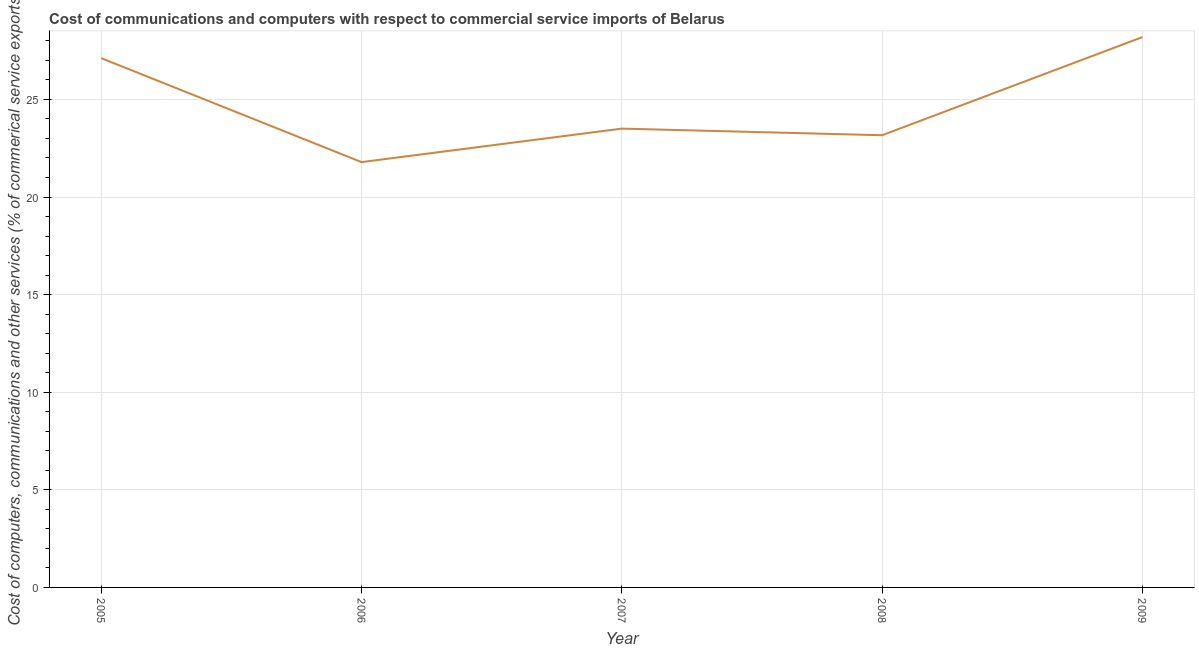What is the cost of communications in 2009?
Your answer should be very brief. 28.19. Across all years, what is the maximum  computer and other services?
Offer a very short reply. 28.19. Across all years, what is the minimum  computer and other services?
Keep it short and to the point. 21.79. In which year was the cost of communications maximum?
Ensure brevity in your answer.  2009. In which year was the cost of communications minimum?
Provide a short and direct response. 2006. What is the sum of the cost of communications?
Give a very brief answer. 123.77. What is the difference between the cost of communications in 2007 and 2008?
Your answer should be compact. 0.34. What is the average  computer and other services per year?
Offer a terse response. 24.75. What is the median cost of communications?
Keep it short and to the point. 23.5. Do a majority of the years between 2006 and 2007 (inclusive) have cost of communications greater than 15 %?
Give a very brief answer. Yes. What is the ratio of the cost of communications in 2007 to that in 2009?
Your answer should be very brief. 0.83. Is the  computer and other services in 2006 less than that in 2008?
Your answer should be compact. Yes. What is the difference between the highest and the second highest cost of communications?
Offer a terse response. 1.08. What is the difference between the highest and the lowest  computer and other services?
Ensure brevity in your answer.  6.41. In how many years, is the cost of communications greater than the average cost of communications taken over all years?
Keep it short and to the point. 2. Does the graph contain grids?
Keep it short and to the point. Yes. What is the title of the graph?
Your answer should be compact. Cost of communications and computers with respect to commercial service imports of Belarus. What is the label or title of the Y-axis?
Offer a terse response. Cost of computers, communications and other services (% of commerical service exports). What is the Cost of computers, communications and other services (% of commerical service exports) in 2005?
Your answer should be compact. 27.11. What is the Cost of computers, communications and other services (% of commerical service exports) in 2006?
Provide a short and direct response. 21.79. What is the Cost of computers, communications and other services (% of commerical service exports) of 2007?
Your response must be concise. 23.5. What is the Cost of computers, communications and other services (% of commerical service exports) in 2008?
Your answer should be compact. 23.17. What is the Cost of computers, communications and other services (% of commerical service exports) of 2009?
Your answer should be compact. 28.19. What is the difference between the Cost of computers, communications and other services (% of commerical service exports) in 2005 and 2006?
Ensure brevity in your answer.  5.33. What is the difference between the Cost of computers, communications and other services (% of commerical service exports) in 2005 and 2007?
Your answer should be very brief. 3.61. What is the difference between the Cost of computers, communications and other services (% of commerical service exports) in 2005 and 2008?
Give a very brief answer. 3.95. What is the difference between the Cost of computers, communications and other services (% of commerical service exports) in 2005 and 2009?
Offer a terse response. -1.08. What is the difference between the Cost of computers, communications and other services (% of commerical service exports) in 2006 and 2007?
Offer a terse response. -1.72. What is the difference between the Cost of computers, communications and other services (% of commerical service exports) in 2006 and 2008?
Keep it short and to the point. -1.38. What is the difference between the Cost of computers, communications and other services (% of commerical service exports) in 2006 and 2009?
Make the answer very short. -6.41. What is the difference between the Cost of computers, communications and other services (% of commerical service exports) in 2007 and 2008?
Ensure brevity in your answer.  0.34. What is the difference between the Cost of computers, communications and other services (% of commerical service exports) in 2007 and 2009?
Offer a terse response. -4.69. What is the difference between the Cost of computers, communications and other services (% of commerical service exports) in 2008 and 2009?
Keep it short and to the point. -5.03. What is the ratio of the Cost of computers, communications and other services (% of commerical service exports) in 2005 to that in 2006?
Your answer should be very brief. 1.24. What is the ratio of the Cost of computers, communications and other services (% of commerical service exports) in 2005 to that in 2007?
Your answer should be compact. 1.15. What is the ratio of the Cost of computers, communications and other services (% of commerical service exports) in 2005 to that in 2008?
Your response must be concise. 1.17. What is the ratio of the Cost of computers, communications and other services (% of commerical service exports) in 2006 to that in 2007?
Offer a terse response. 0.93. What is the ratio of the Cost of computers, communications and other services (% of commerical service exports) in 2006 to that in 2008?
Make the answer very short. 0.94. What is the ratio of the Cost of computers, communications and other services (% of commerical service exports) in 2006 to that in 2009?
Keep it short and to the point. 0.77. What is the ratio of the Cost of computers, communications and other services (% of commerical service exports) in 2007 to that in 2009?
Provide a short and direct response. 0.83. What is the ratio of the Cost of computers, communications and other services (% of commerical service exports) in 2008 to that in 2009?
Provide a succinct answer. 0.82. 